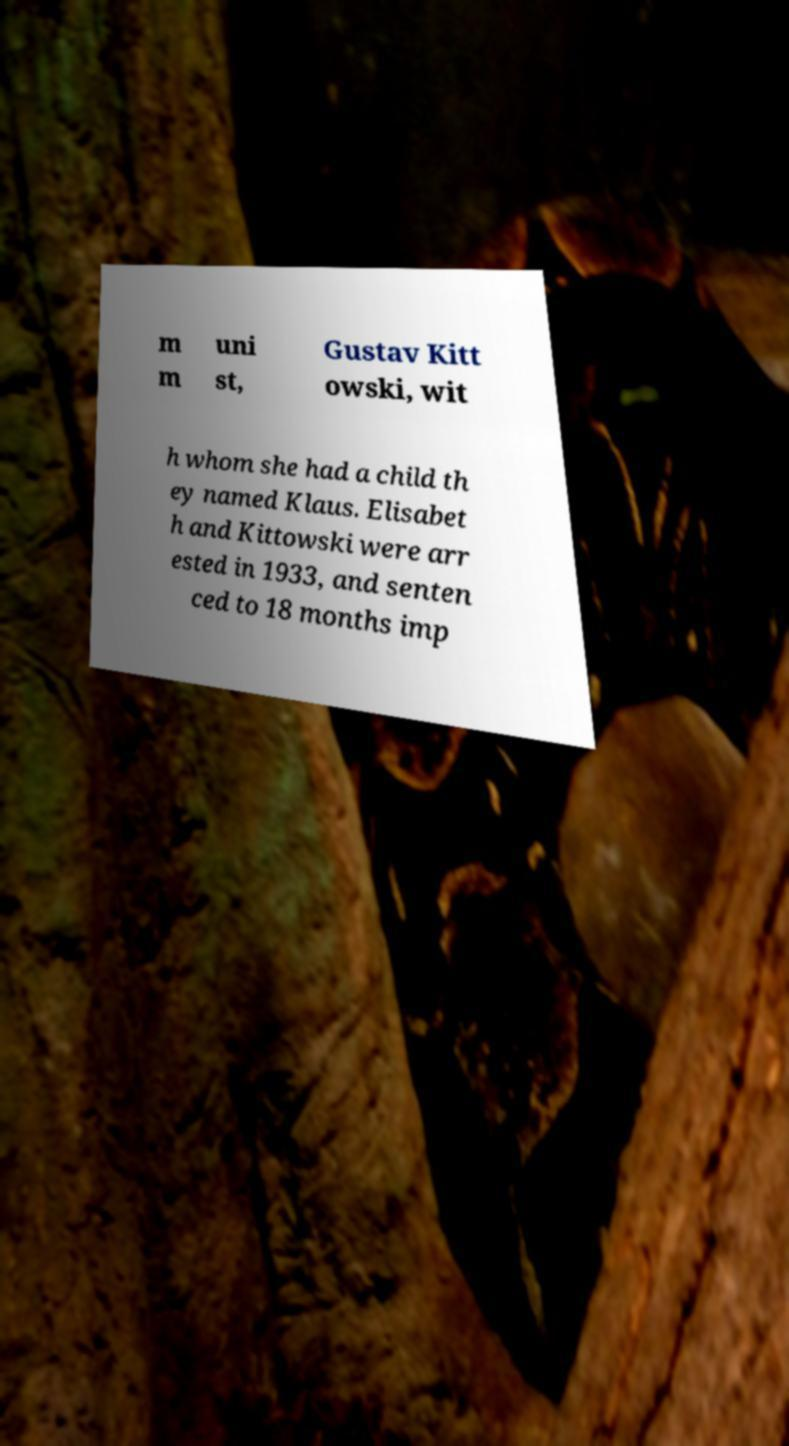Please read and relay the text visible in this image. What does it say? m m uni st, Gustav Kitt owski, wit h whom she had a child th ey named Klaus. Elisabet h and Kittowski were arr ested in 1933, and senten ced to 18 months imp 